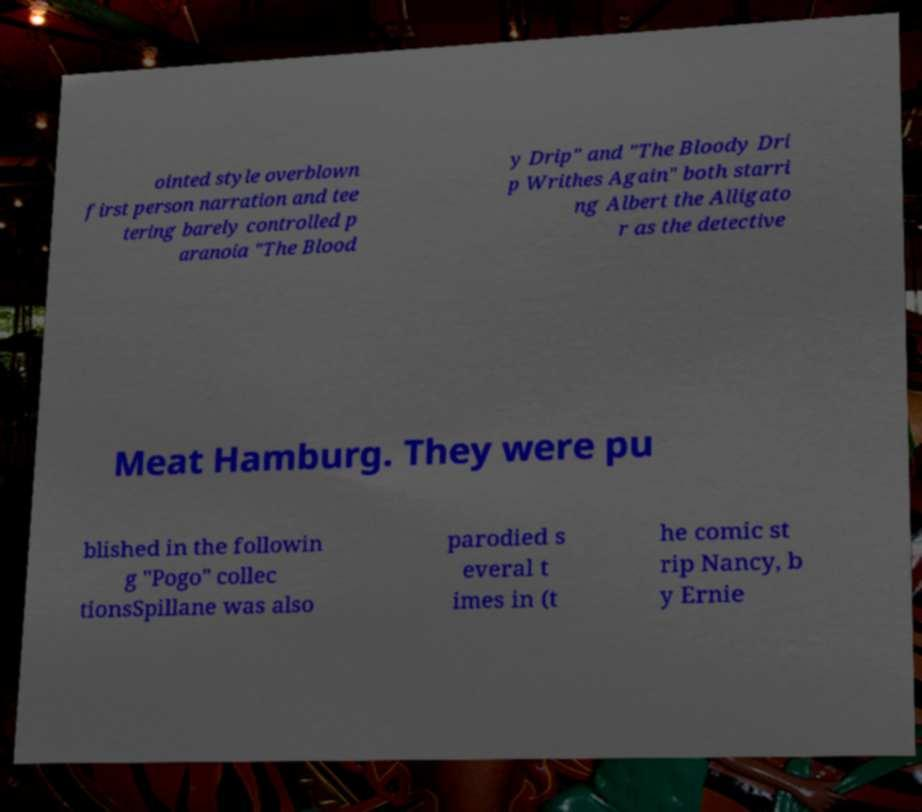Please identify and transcribe the text found in this image. ointed style overblown first person narration and tee tering barely controlled p aranoia "The Blood y Drip" and "The Bloody Dri p Writhes Again" both starri ng Albert the Alligato r as the detective Meat Hamburg. They were pu blished in the followin g "Pogo" collec tionsSpillane was also parodied s everal t imes in (t he comic st rip Nancy, b y Ernie 